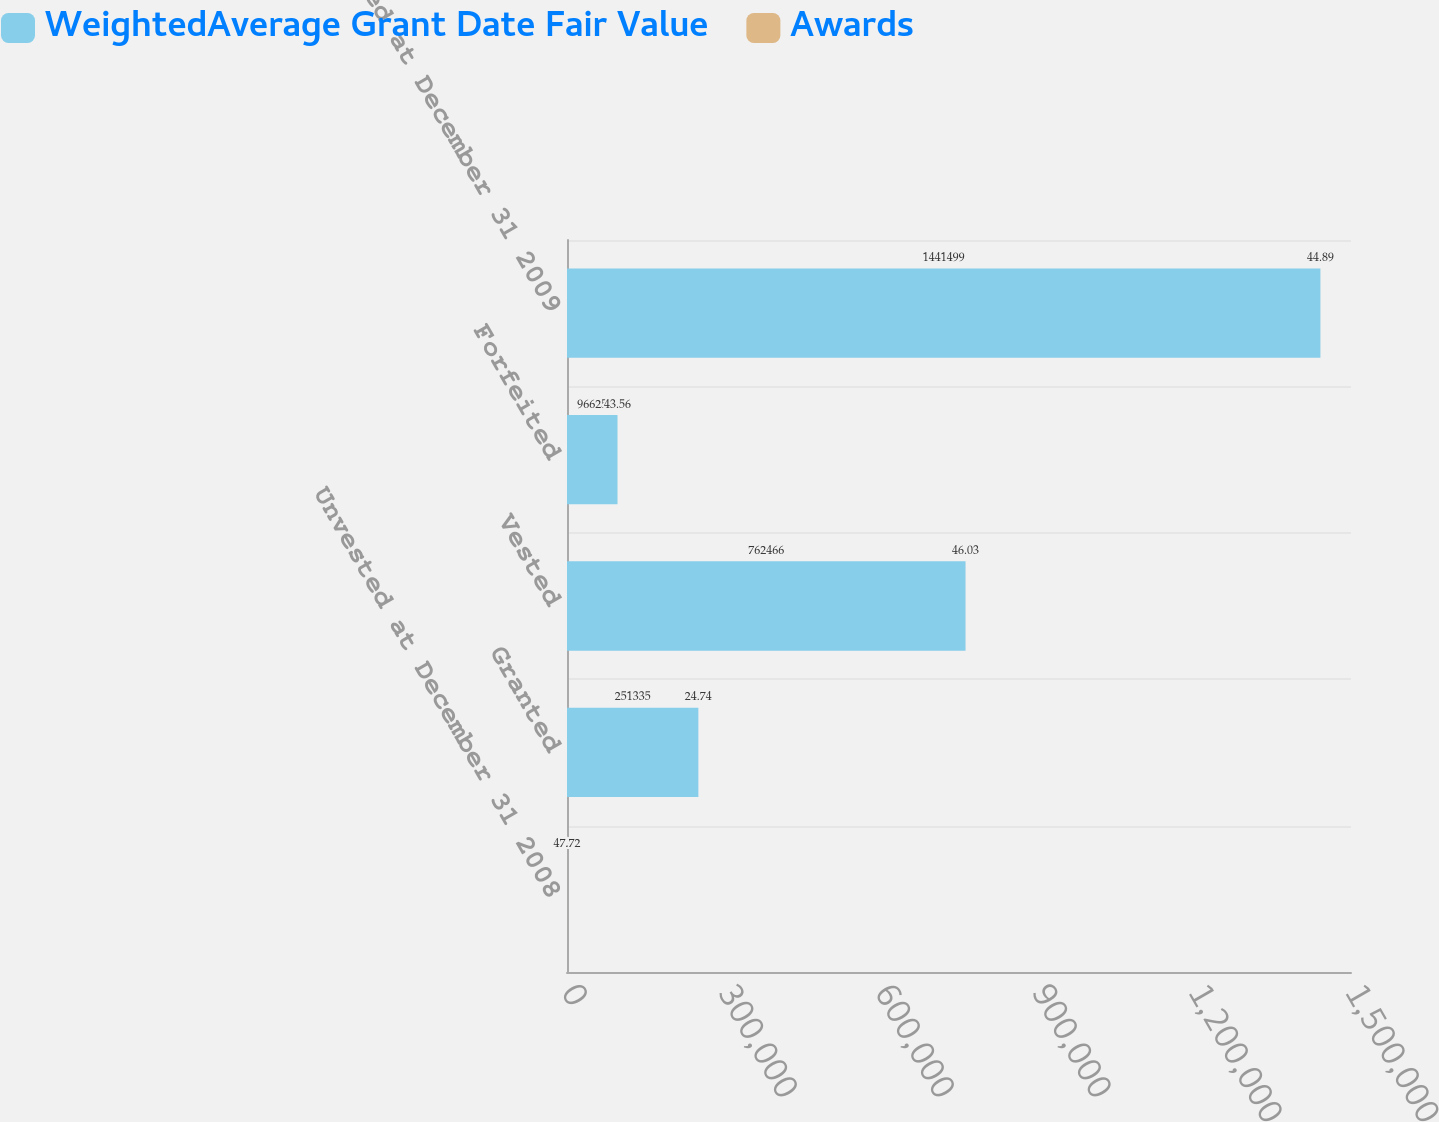Convert chart. <chart><loc_0><loc_0><loc_500><loc_500><stacked_bar_chart><ecel><fcel>Unvested at December 31 2008<fcel>Granted<fcel>Vested<fcel>Forfeited<fcel>Unvested at December 31 2009<nl><fcel>WeightedAverage Grant Date Fair Value<fcel>47.72<fcel>251335<fcel>762466<fcel>96625<fcel>1.4415e+06<nl><fcel>Awards<fcel>47.72<fcel>24.74<fcel>46.03<fcel>43.56<fcel>44.89<nl></chart> 